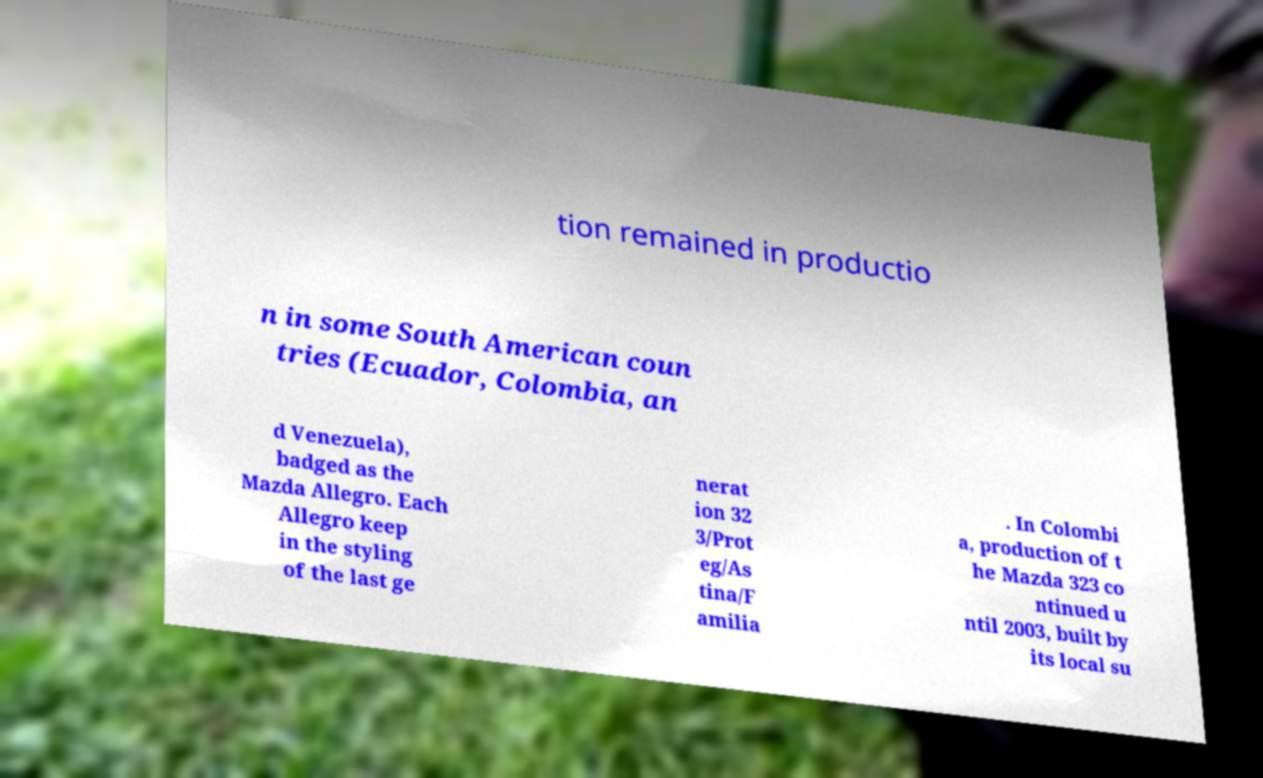Could you assist in decoding the text presented in this image and type it out clearly? tion remained in productio n in some South American coun tries (Ecuador, Colombia, an d Venezuela), badged as the Mazda Allegro. Each Allegro keep in the styling of the last ge nerat ion 32 3/Prot eg/As tina/F amilia . In Colombi a, production of t he Mazda 323 co ntinued u ntil 2003, built by its local su 